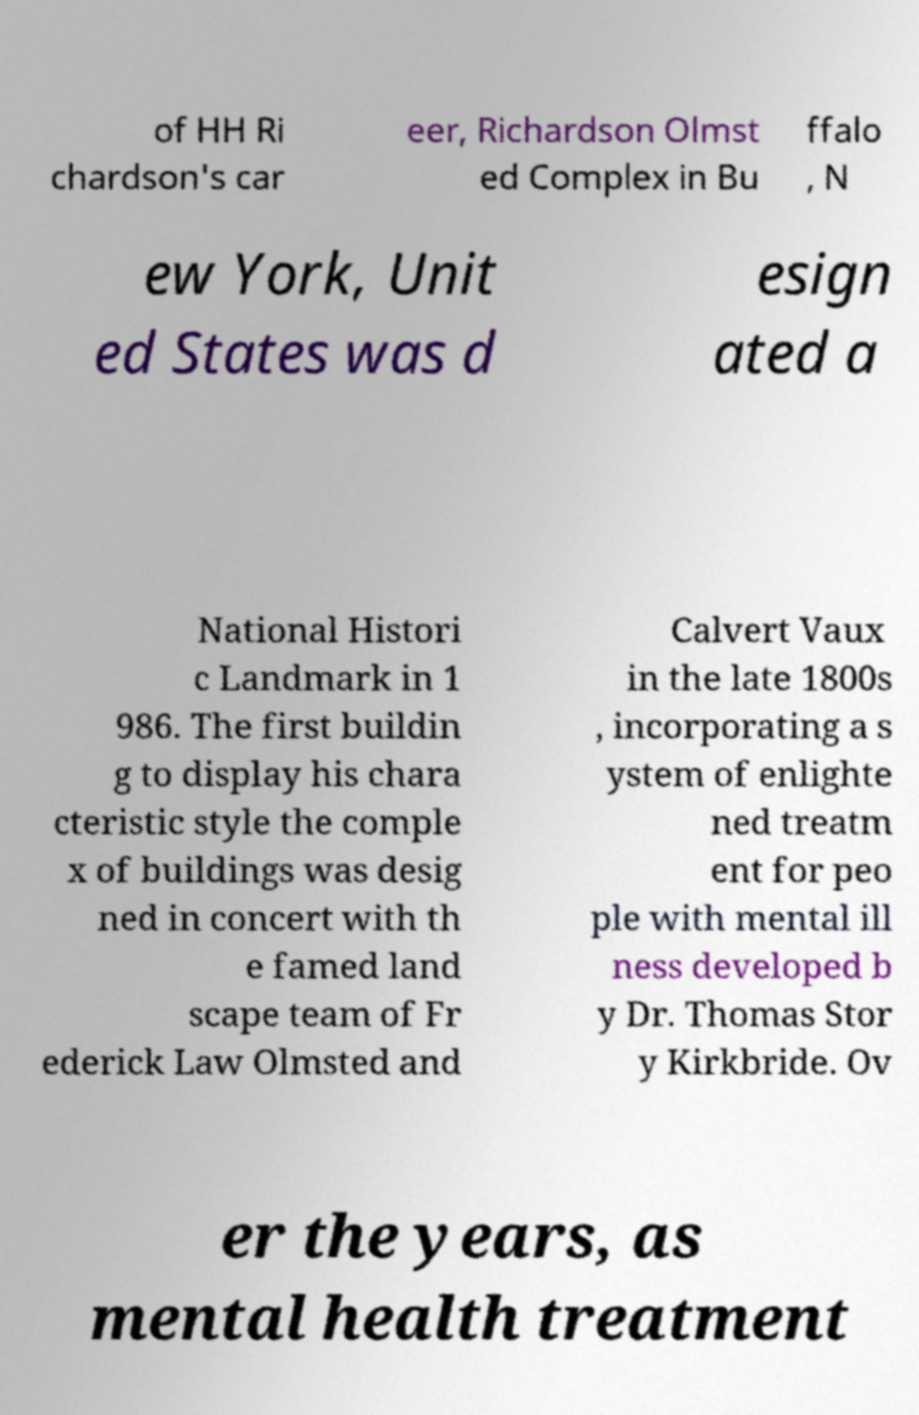Please identify and transcribe the text found in this image. of HH Ri chardson's car eer, Richardson Olmst ed Complex in Bu ffalo , N ew York, Unit ed States was d esign ated a National Histori c Landmark in 1 986. The first buildin g to display his chara cteristic style the comple x of buildings was desig ned in concert with th e famed land scape team of Fr ederick Law Olmsted and Calvert Vaux in the late 1800s , incorporating a s ystem of enlighte ned treatm ent for peo ple with mental ill ness developed b y Dr. Thomas Stor y Kirkbride. Ov er the years, as mental health treatment 